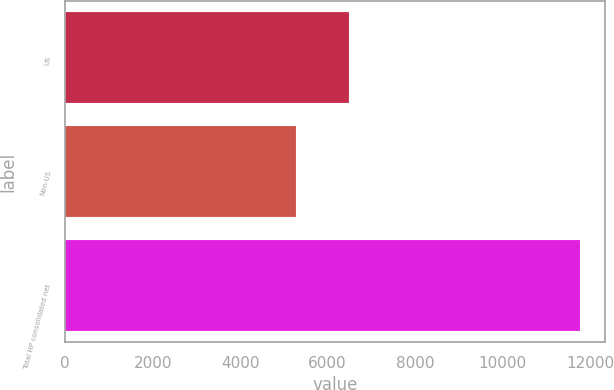Convert chart. <chart><loc_0><loc_0><loc_500><loc_500><bar_chart><fcel>US<fcel>Non-US<fcel>Total HP consolidated net<nl><fcel>6479<fcel>5284<fcel>11763<nl></chart> 